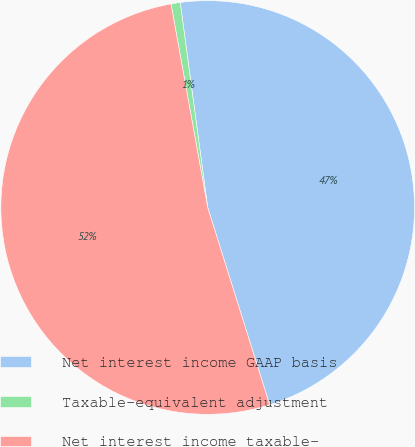Convert chart to OTSL. <chart><loc_0><loc_0><loc_500><loc_500><pie_chart><fcel>Net interest income GAAP basis<fcel>Taxable-equivalent adjustment<fcel>Net interest income taxable-<nl><fcel>47.27%<fcel>0.72%<fcel>52.0%<nl></chart> 